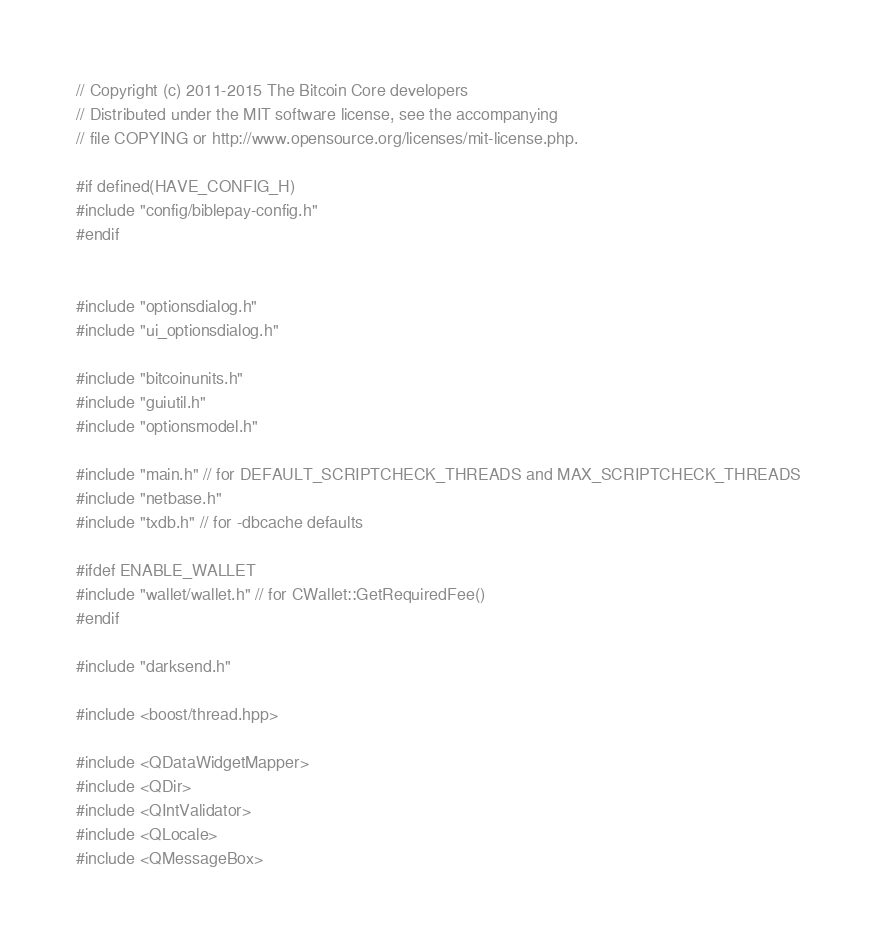Convert code to text. <code><loc_0><loc_0><loc_500><loc_500><_C++_>// Copyright (c) 2011-2015 The Bitcoin Core developers
// Distributed under the MIT software license, see the accompanying
// file COPYING or http://www.opensource.org/licenses/mit-license.php.

#if defined(HAVE_CONFIG_H)
#include "config/biblepay-config.h"
#endif


#include "optionsdialog.h"
#include "ui_optionsdialog.h"

#include "bitcoinunits.h"
#include "guiutil.h"
#include "optionsmodel.h"

#include "main.h" // for DEFAULT_SCRIPTCHECK_THREADS and MAX_SCRIPTCHECK_THREADS
#include "netbase.h"
#include "txdb.h" // for -dbcache defaults

#ifdef ENABLE_WALLET
#include "wallet/wallet.h" // for CWallet::GetRequiredFee()
#endif

#include "darksend.h"

#include <boost/thread.hpp>

#include <QDataWidgetMapper>
#include <QDir>
#include <QIntValidator>
#include <QLocale>
#include <QMessageBox></code> 